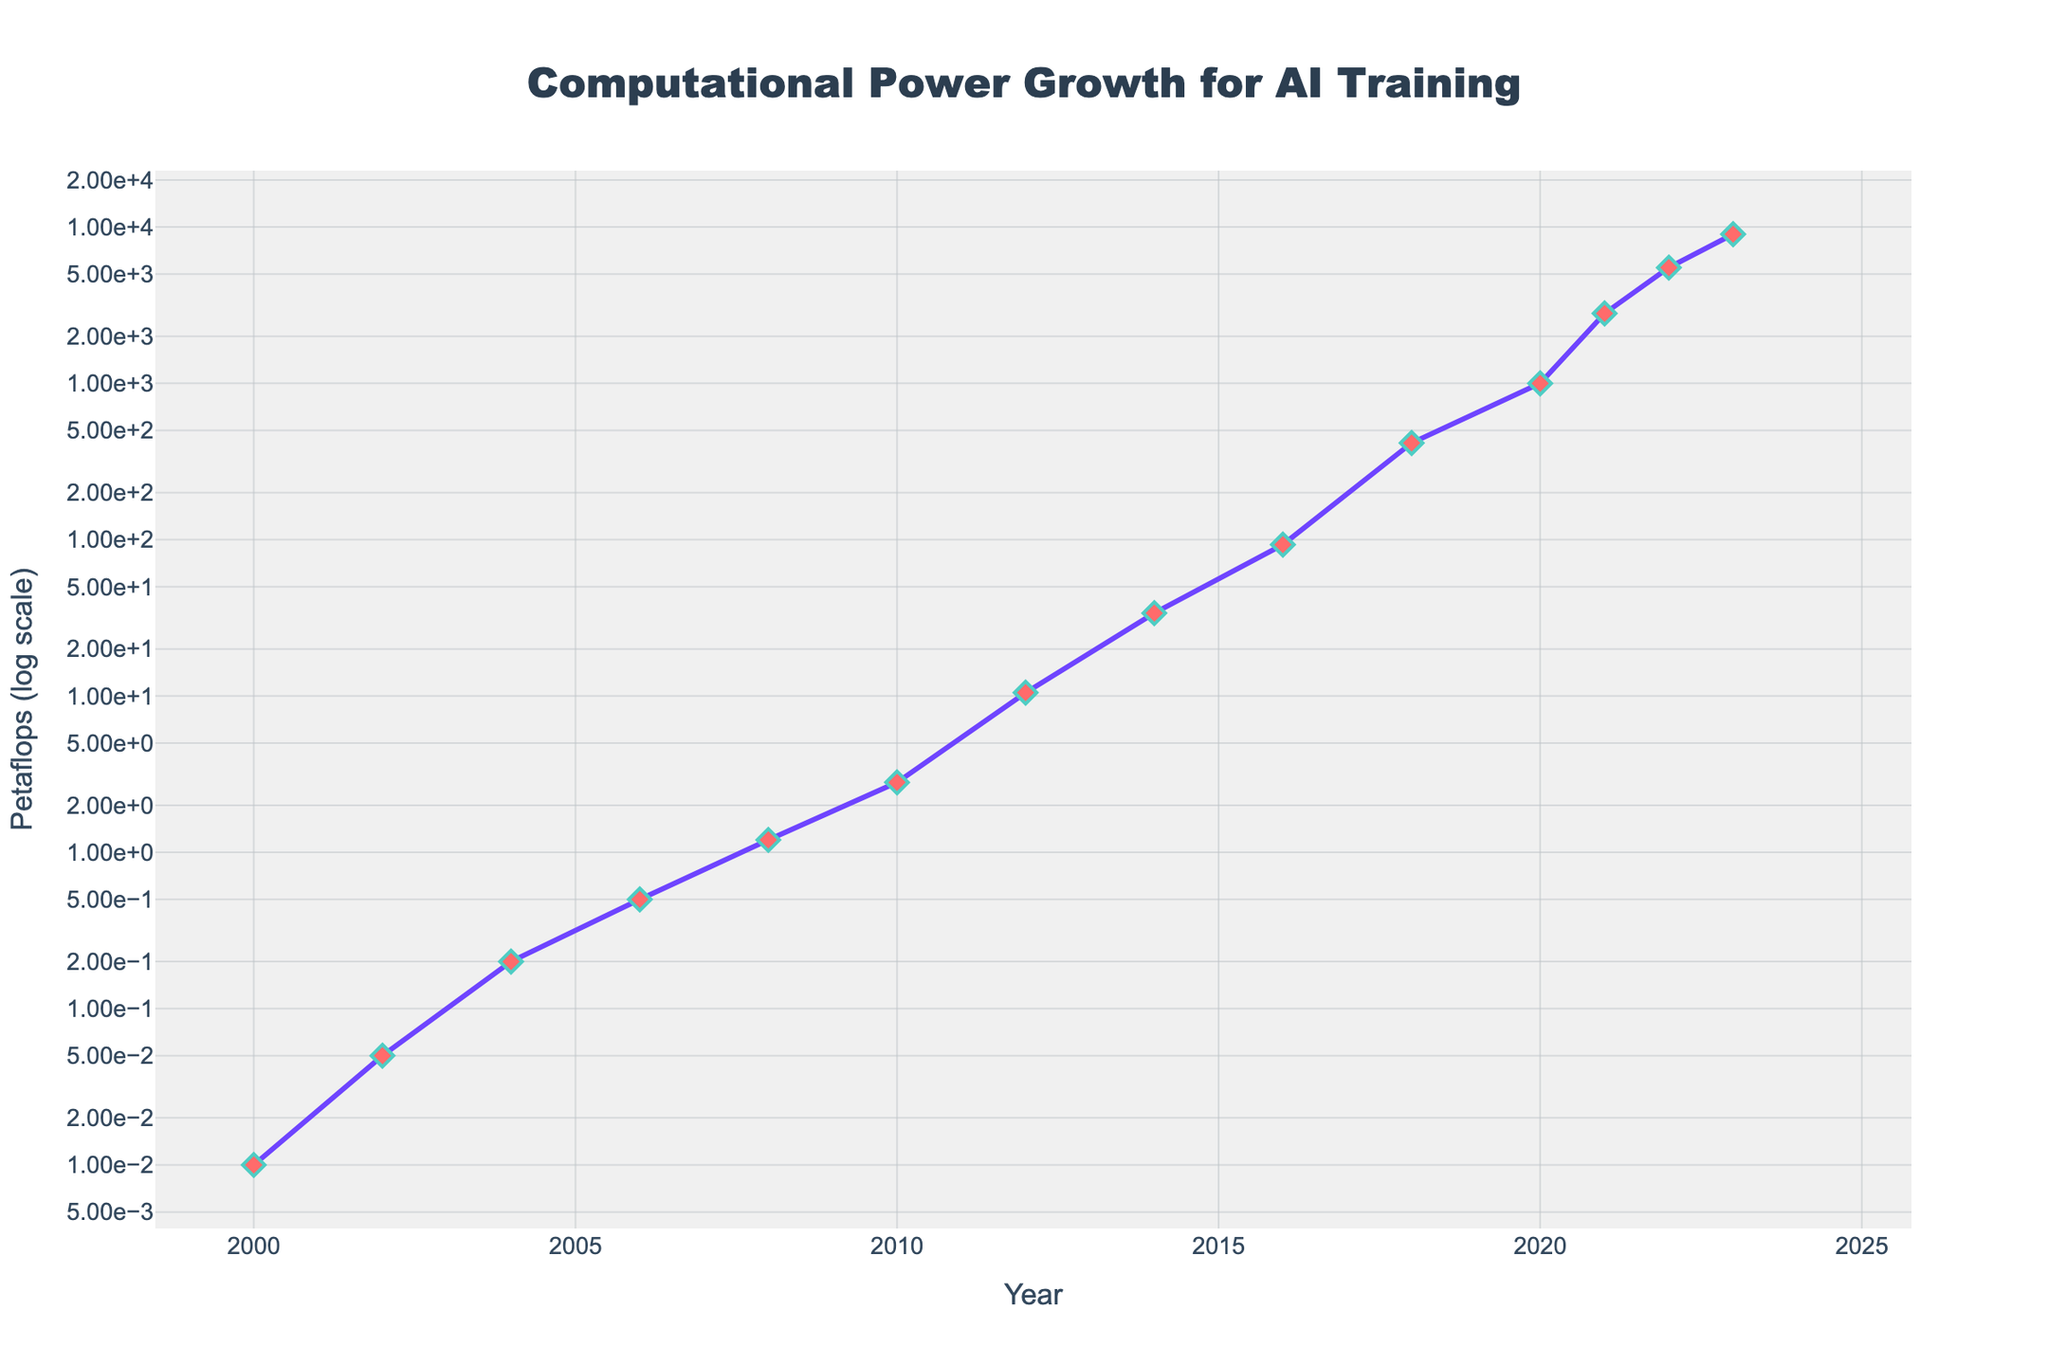What's the general trend of computational power for AI training from 2000 to 2023? The computational power shows an exponential increase from 0.01 Petaflops in 2000 to 9000 Petaflops in 2023.
Answer: Exponential increase In which year did the computational power first exceed 100 Petaflops? The computational power first exceeded 100 Petaflops in 2016.
Answer: 2016 What is the approximate difference in computational power between 2010 and 2020? The computational power in 2010 was 2.8 Petaflops, and in 2020, it was 1000 Petaflops. The difference is approximately 997.2 Petaflops.
Answer: 997.2 Petaflops How many years did it take for the computational power to grow from 1.2 Petaflops to 415.5 Petaflops? The computational power was 1.2 Petaflops in 2008 and 415.5 Petaflops in 2018, so it took 10 years.
Answer: 10 years Which year saw the highest year-on-year growth in computational power, and what was the increase? From 2022 to 2023, computational power increased from 5500 Petaflops to 9000 Petaflops, an increase of 3500 Petaflops, the highest year-on-year growth.
Answer: 2023, 3500 Petaflops What visual markers are used to represent the data points on the line chart? The data points are represented by diamond-shaped markers colored red, with a contrasting border and line connecting them.
Answer: Diamond-shaped markers with red color What was the computational power in 2012, and how does it compare to that in 2008? In 2012, the computational power was 10.5 Petaflops, compared to 1.2 Petaflops in 2008, showing a significant increase.
Answer: 10.5 Petaflops; significant increase What type of scale is used for the y-axis, and why is it appropriate for this data? A logarithmic scale is used for the y-axis, which is appropriate because it effectively represents the exponential growth of computational power.
Answer: Logarithmic scale 